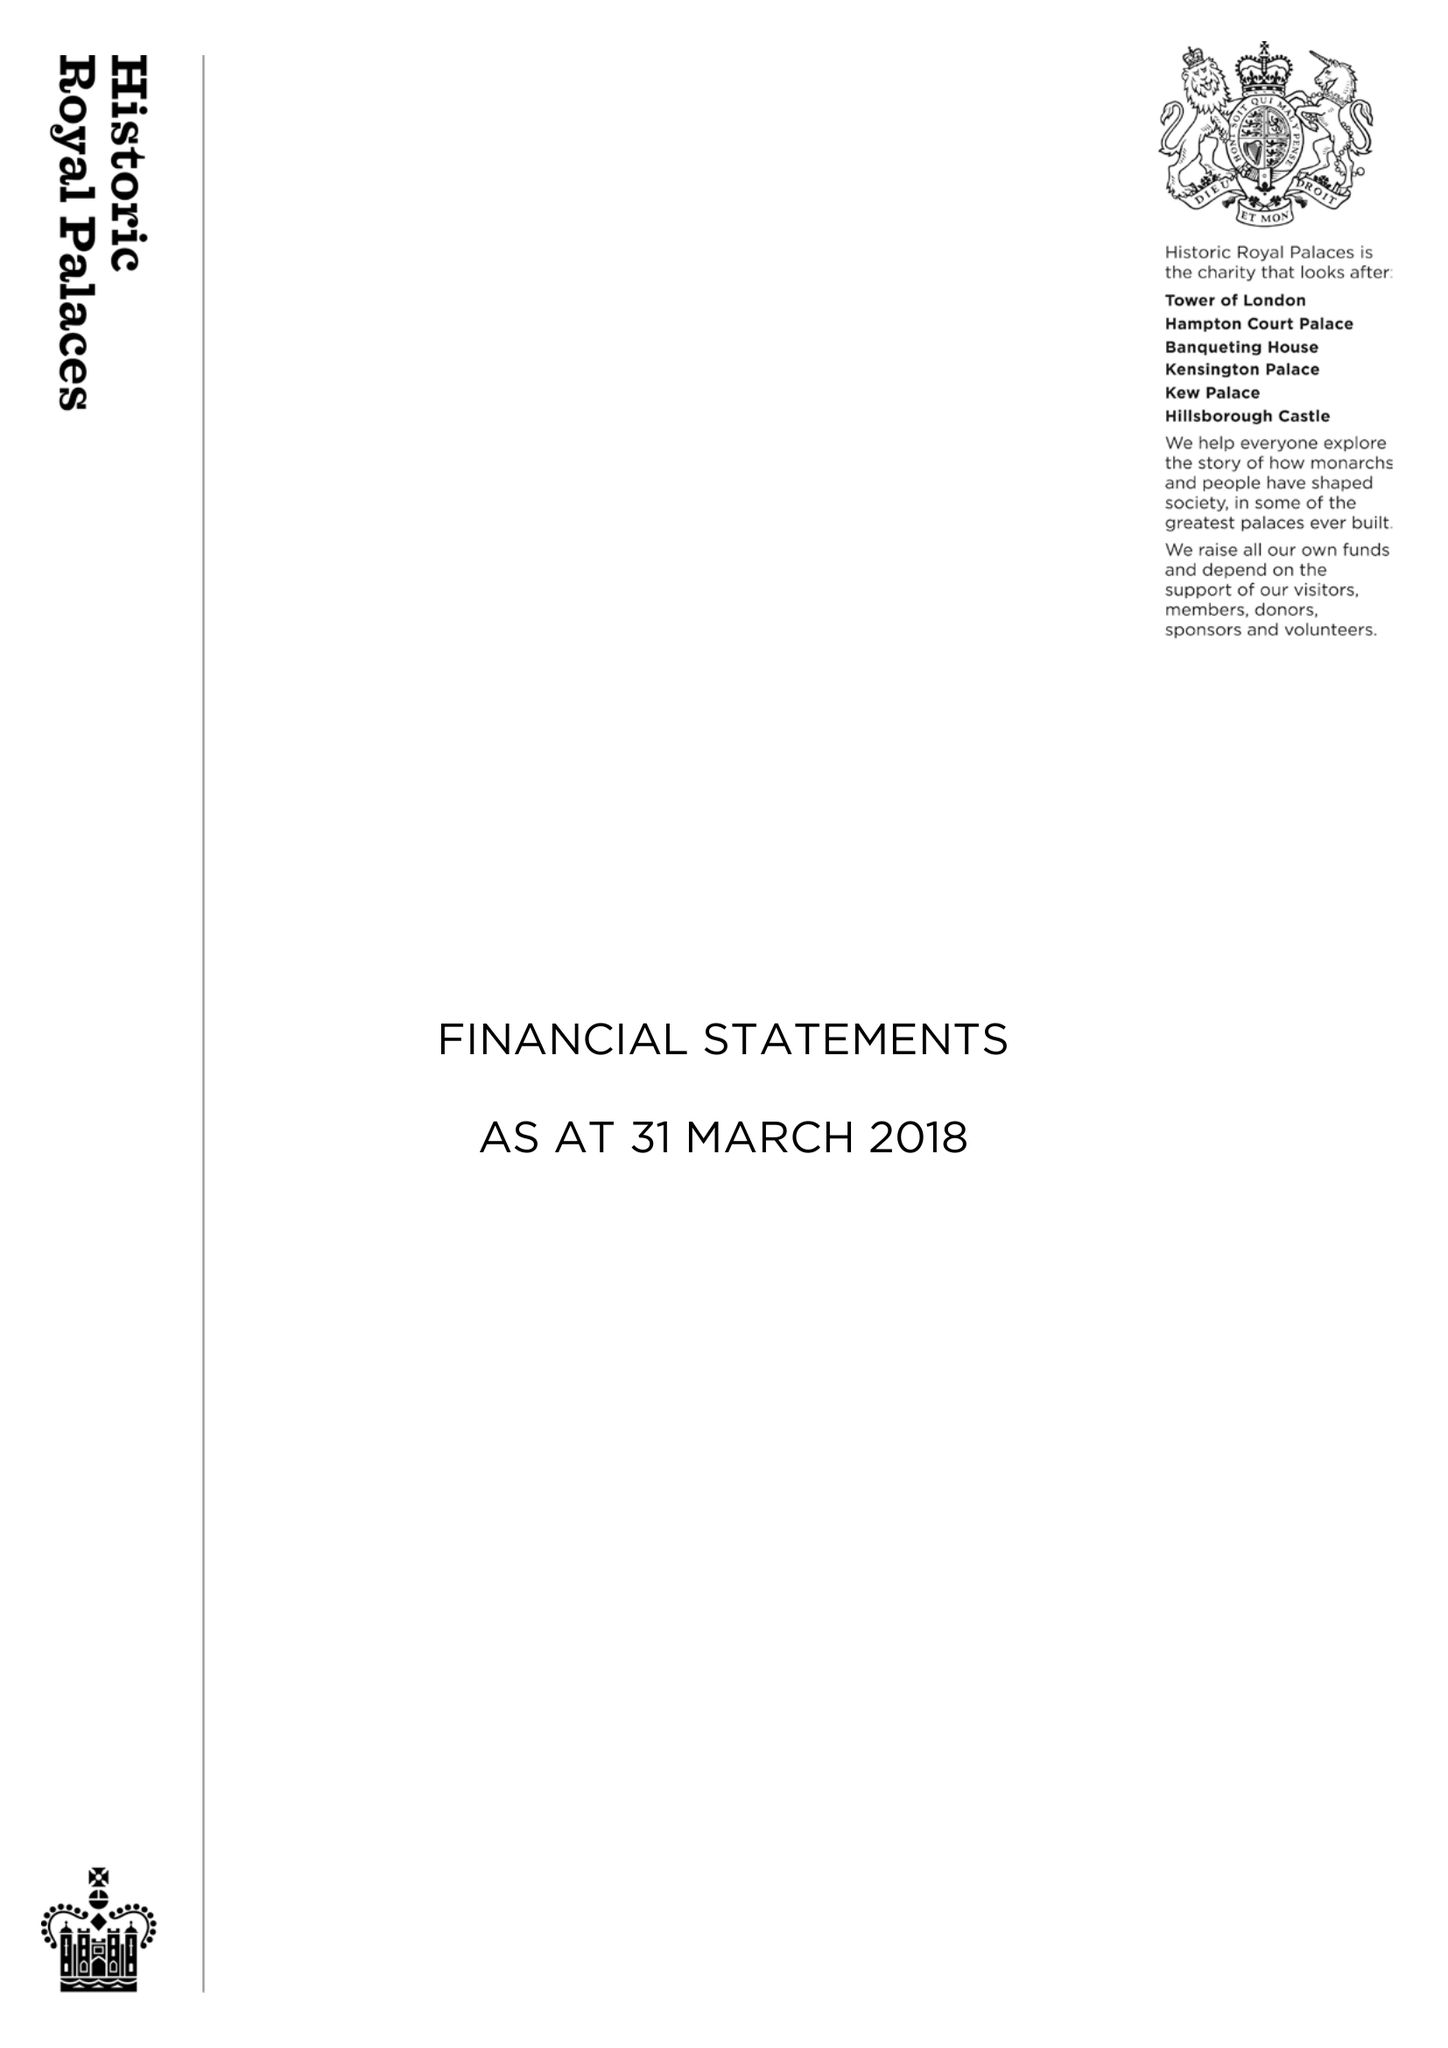What is the value for the charity_number?
Answer the question using a single word or phrase. 1068852 